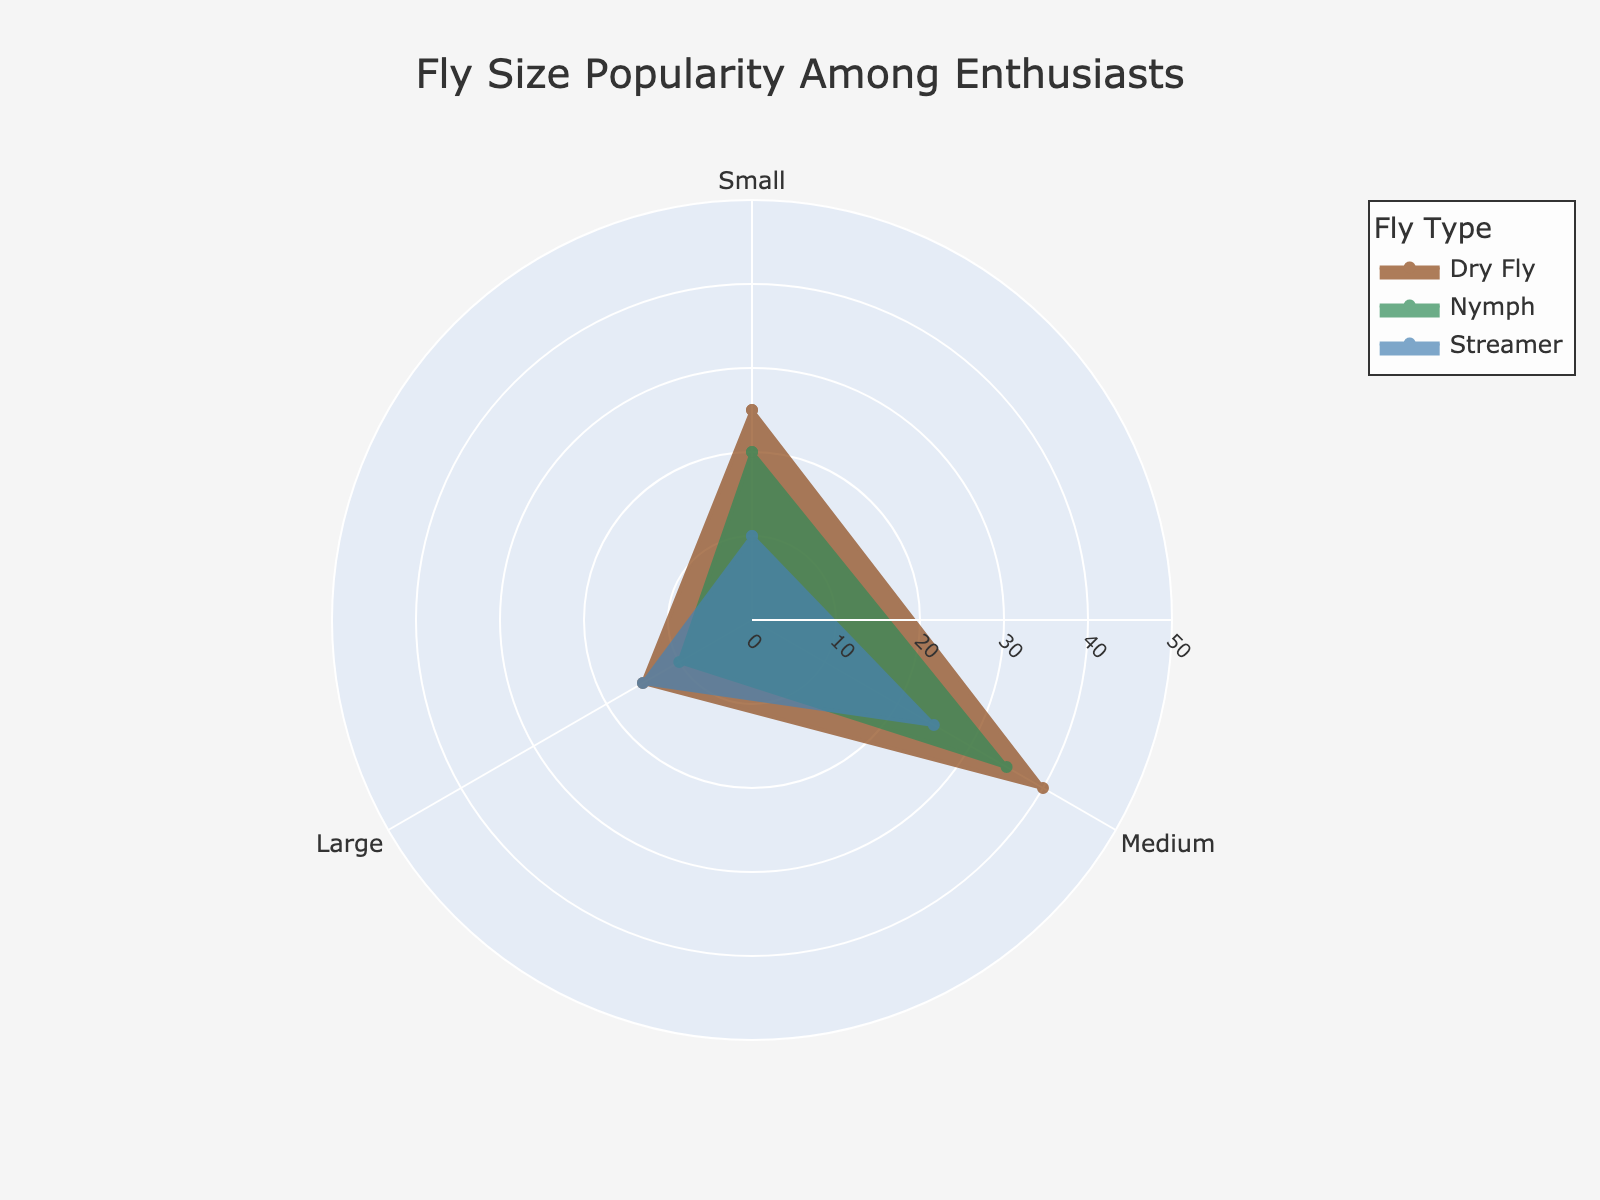What is the title of the chart? The title of the chart is displayed at the top and reads "Fly Size Popularity Among Enthusiasts".
Answer: Fly Size Popularity Among Enthusiasts How many categories of flies are included in the chart? The chart has three distinct traces, each representing a different category of fly: Dry Fly, Nymph, and Streamer.
Answer: 3 Which fly size is the most popular among enthusiasts? By looking at the chart, the category with the highest percentage for any fly size is Medium Dry Fly, recording 40%.
Answer: Medium Dry Fly Which category has the smallest percentage for Large flies? For Large flies, the Streamer category has the lowest percentage, with only 15% shown in the chart.
Answer: Streamer Between Small and Medium sizes in the Nymph category, which one is more popular and by how much? By examining the Nymph section of the chart, Small Nymphs have a 20% popularity, while Medium Nymphs have 35%. The difference between them is 35% - 20% = 15%.
Answer: Medium by 15% What is the sum of the percentages for all fly sizes in the Dry Fly category? Adding up the percentages for Small, Medium, and Large in the Dry Fly category: 25% + 40% + 15% = 80%.
Answer: 80% Which category has the highest percentage for Small flies? In the Small flies section, Dry Fly has the highest percentage at 25% as per the chart.
Answer: Dry Fly What is the average percentage for all sizes in the Streamer category? The percentages for Streamer are 10% for Small, 25% for Medium, and 15% for Large. The average percentage can be found by (10% + 25% + 15%) / 3 = 50% / 3 ≈ 16.67%.
Answer: 16.67% How does the popularity of Large Dry Flies compare to Large Nymphs? According to the chart, Large Dry Flies have a popularity of 15%, whereas Large Nymphs have 10%. Hence, Large Dry Flies are more popular by 5%.
Answer: Dry Flies by 5% If you combine the percentages of Medium sizes from all categories, what is the total? Adding the percentages for Medium sizes from Dry Fly (40%), Nymph (35%), and Streamer (25%), you get 40% + 35% + 25% = 100%.
Answer: 100% 